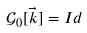<formula> <loc_0><loc_0><loc_500><loc_500>\mathcal { G } _ { 0 } [ \vec { k } ] = I d</formula> 